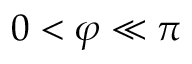Convert formula to latex. <formula><loc_0><loc_0><loc_500><loc_500>0 < \varphi \ll \pi</formula> 